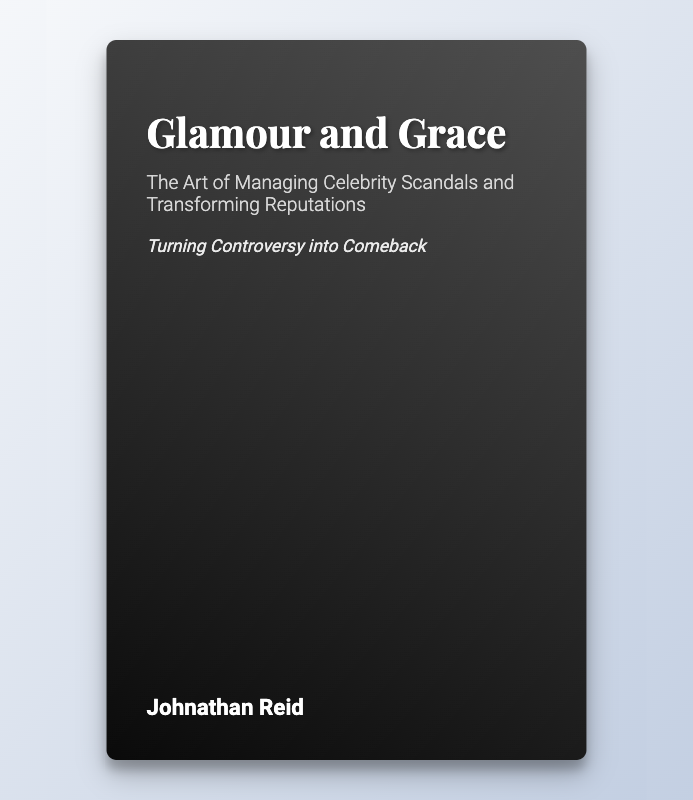What is the title of the book? The title of the book is prominently displayed on the cover.
Answer: Glamour and Grace Who is the author of the book? The author's name is listed on the bottom of the cover.
Answer: Johnathan Reid What is the tagline of the book? The tagline is located under the subtitle and conveys the book's theme.
Answer: Turning Controversy into Comeback What is one key theme discussed in the book? The themes are highlighted in specific sections focusing on reputation management.
Answer: Managing Celebrity Scandals What type of analysis does the book include? The cover mentions a section dedicated to in-depth exploration of certain cases.
Answer: Case Studies and Success Stories Which celebrity is mentioned as having a successful reputation turnaround? The book provides a specific example of a celebrity's comeback journey.
Answer: Robert Downey Jr What aspect does the section on legal considerations cover? This section addresses specific legal issues related to reputation management.
Answer: Defamation What is one tactic suggested for engaging with media during a scandal? The book offers strategies within its media management section.
Answer: Strategic engagement What kind of considerations does the author emphasize in the book? The author highlights a particular set of factors crucial for managing celebrity reputations.
Answer: Ethical Considerations 